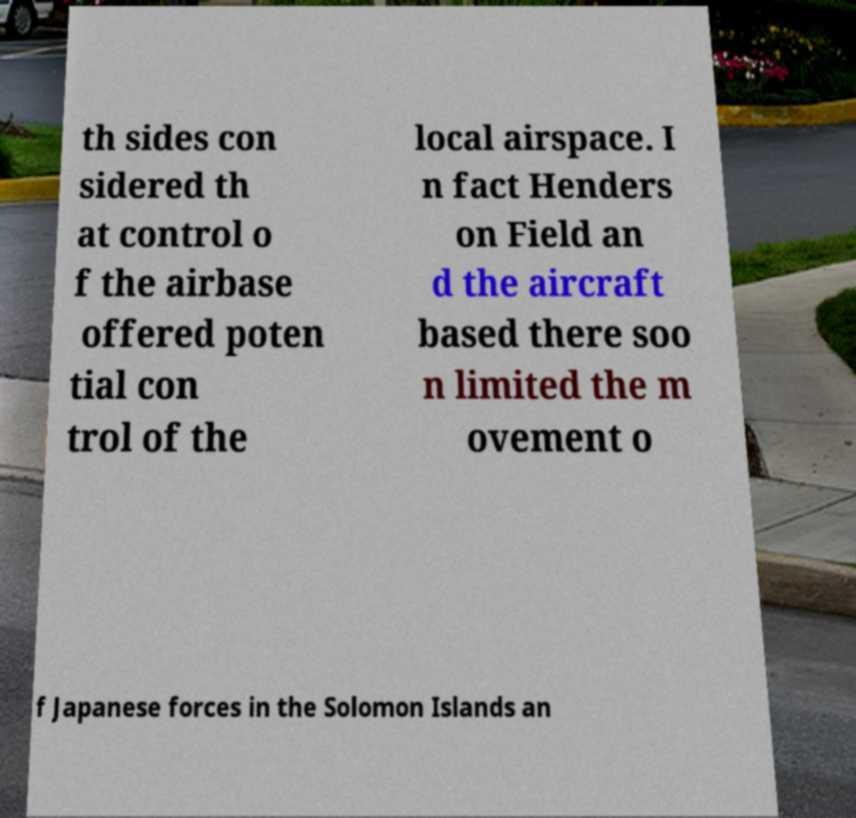For documentation purposes, I need the text within this image transcribed. Could you provide that? th sides con sidered th at control o f the airbase offered poten tial con trol of the local airspace. I n fact Henders on Field an d the aircraft based there soo n limited the m ovement o f Japanese forces in the Solomon Islands an 